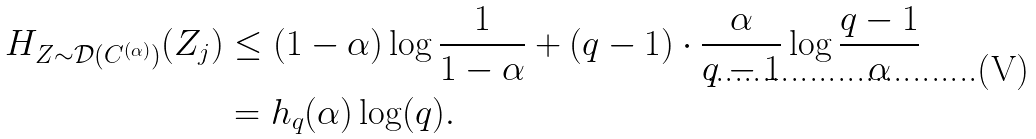Convert formula to latex. <formula><loc_0><loc_0><loc_500><loc_500>H _ { Z \sim \mathcal { D } ( C ^ { ( \alpha ) } ) } ( Z _ { j } ) & \leq ( 1 - \alpha ) \log \frac { 1 } { 1 - \alpha } + ( q - 1 ) \cdot \frac { \alpha } { q - 1 } \log \frac { q - 1 } { \alpha } \\ & = h _ { q } ( \alpha ) \log ( q ) .</formula> 